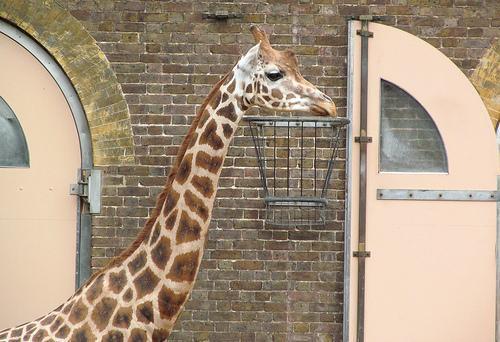How many giraffes are shown?
Give a very brief answer. 1. How many pink doors are there?
Give a very brief answer. 2. How many giraffe are in the scene?
Give a very brief answer. 1. How many animals are there?
Give a very brief answer. 1. 